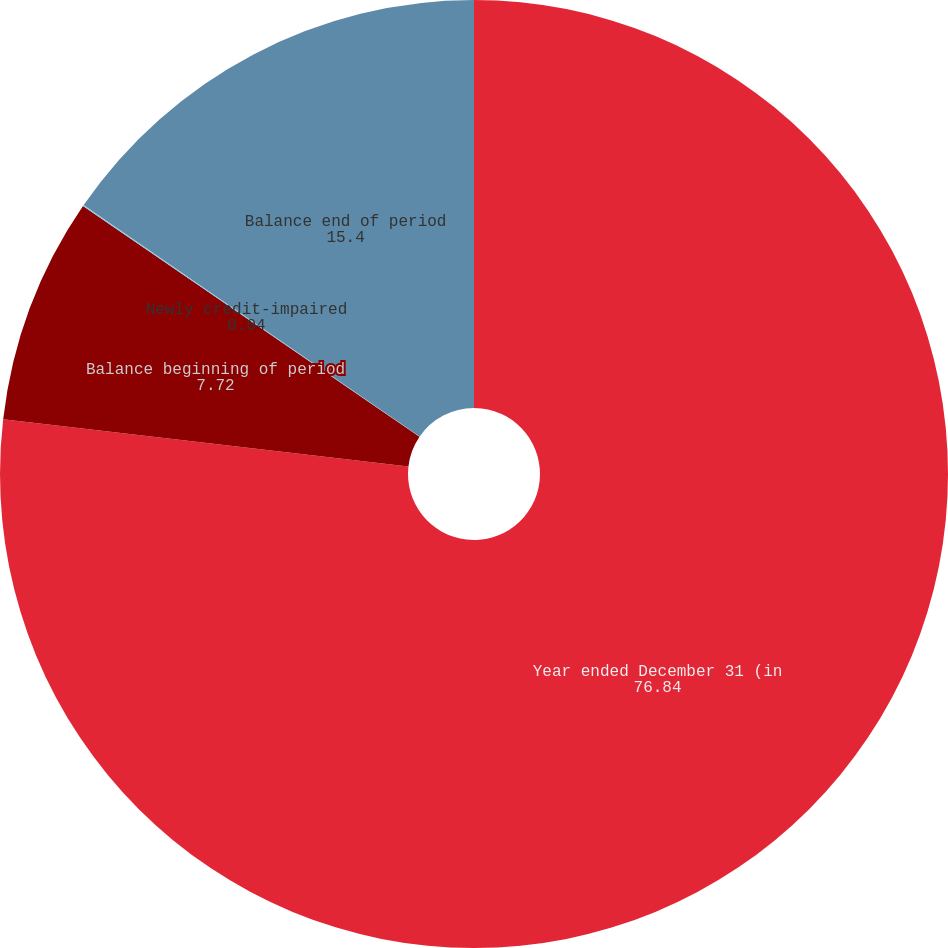<chart> <loc_0><loc_0><loc_500><loc_500><pie_chart><fcel>Year ended December 31 (in<fcel>Balance beginning of period<fcel>Newly credit-impaired<fcel>Balance end of period<nl><fcel>76.84%<fcel>7.72%<fcel>0.04%<fcel>15.4%<nl></chart> 